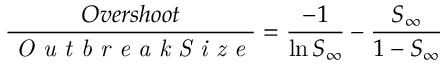Convert formula to latex. <formula><loc_0><loc_0><loc_500><loc_500>\frac { O v e r s h o o t } { O u t b r e a k S i z e } = \frac { - 1 } { \ln S _ { \infty } } - \frac { S _ { \infty } } { 1 - S _ { \infty } }</formula> 